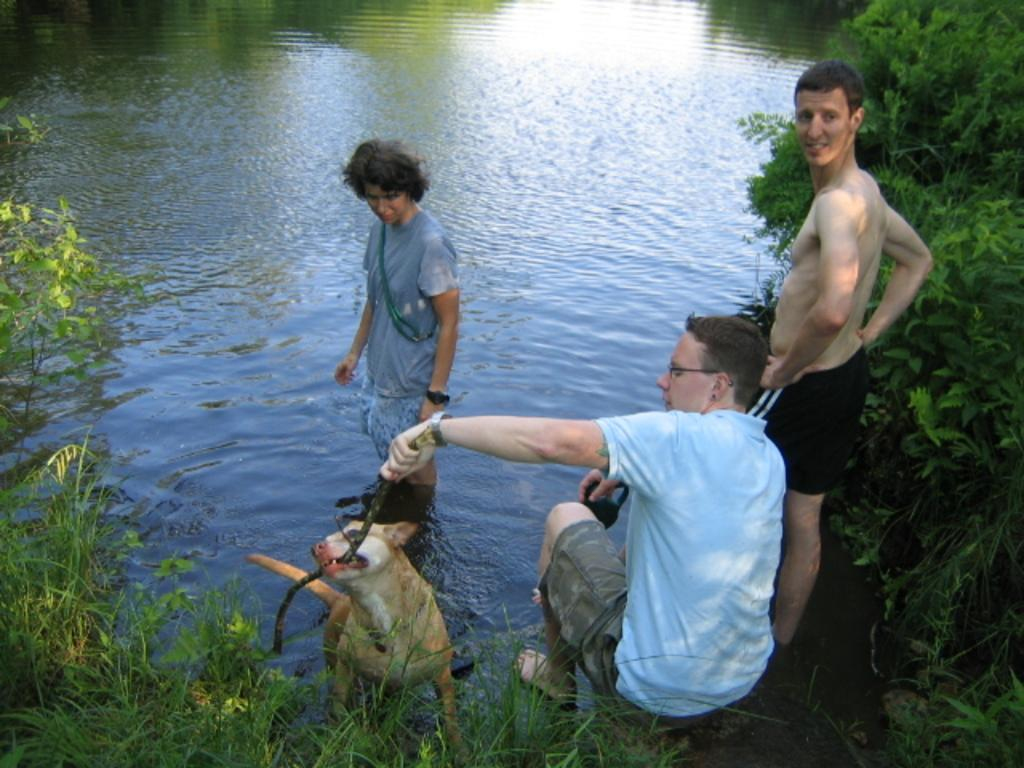How many men are in the image? There are three men in the image. What is one of the men doing in the image? One of the men is standing in water. What is another man holding in his hand? Another man is holding a stick in his hand. What other living creature is present in the image? There is a dog in the image. What can be seen in the background of the image? There is water and trees visible in the background of the image. What type of noise is the ice making in the image? There is no ice present in the image, so it cannot make any noise. 